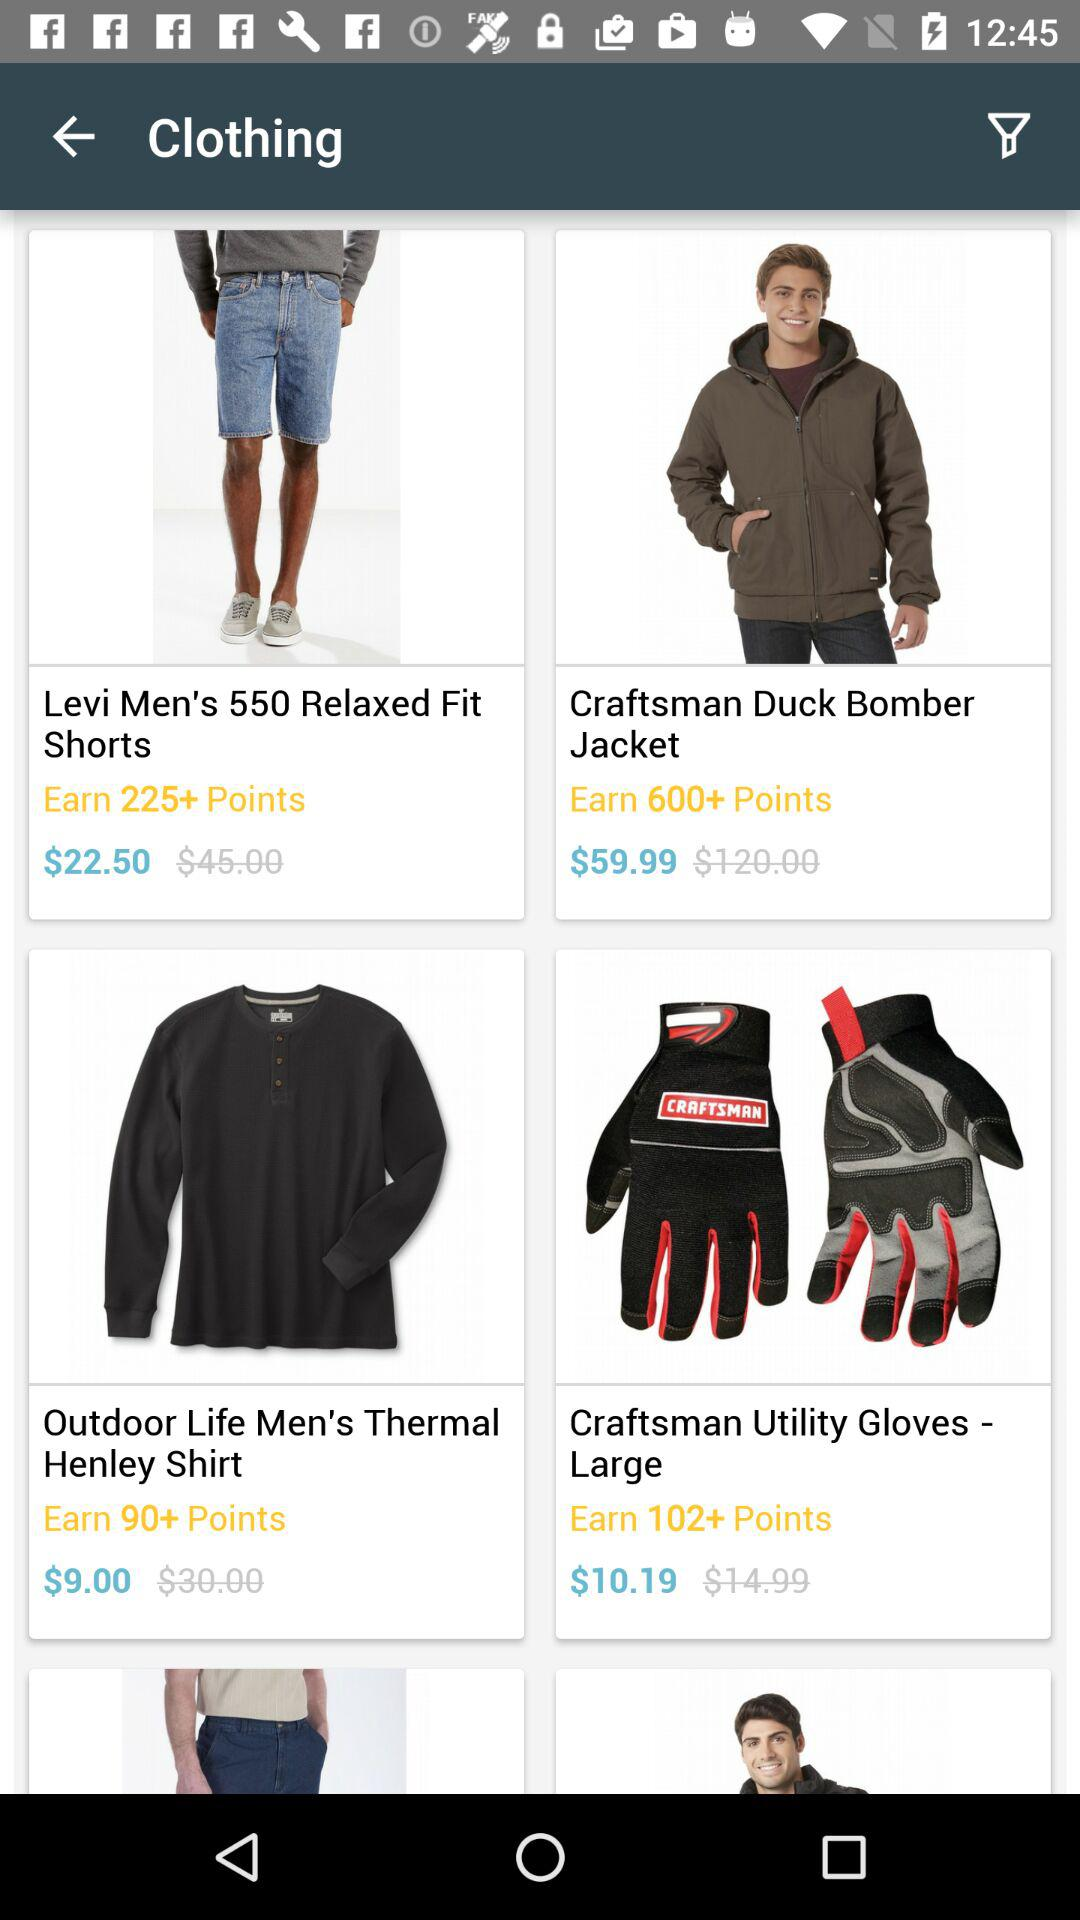What is the price of "Outdoor Life Men's Thermal Henley Shirt"? The price of "Outdoor Life Men's Thermal Henley Shirt" is $9.00. 